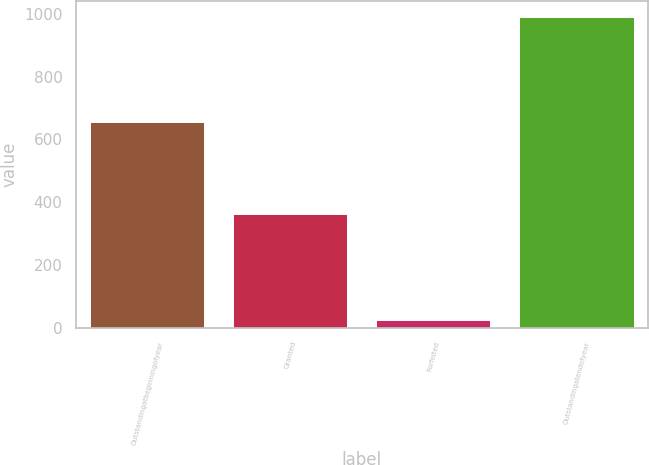<chart> <loc_0><loc_0><loc_500><loc_500><bar_chart><fcel>Outstandingatbeginningofyear<fcel>Granted<fcel>Forfeited<fcel>Outstandingatendofyear<nl><fcel>655<fcel>362<fcel>25<fcel>992<nl></chart> 